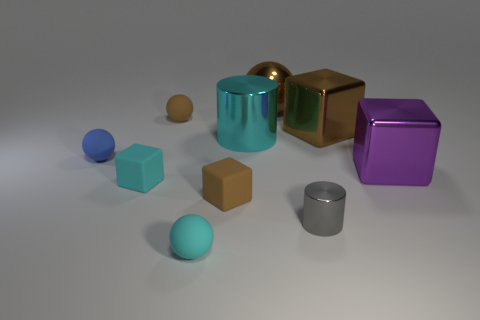Describe the setting in which these objects are placed. The objects are arranged on a smooth, flat surface that appears to be indoors due to the controlled lighting and absence of any natural elements. The neutral background suggests a studio-like environment, possibly for the purpose of a display or an artistic composition. 